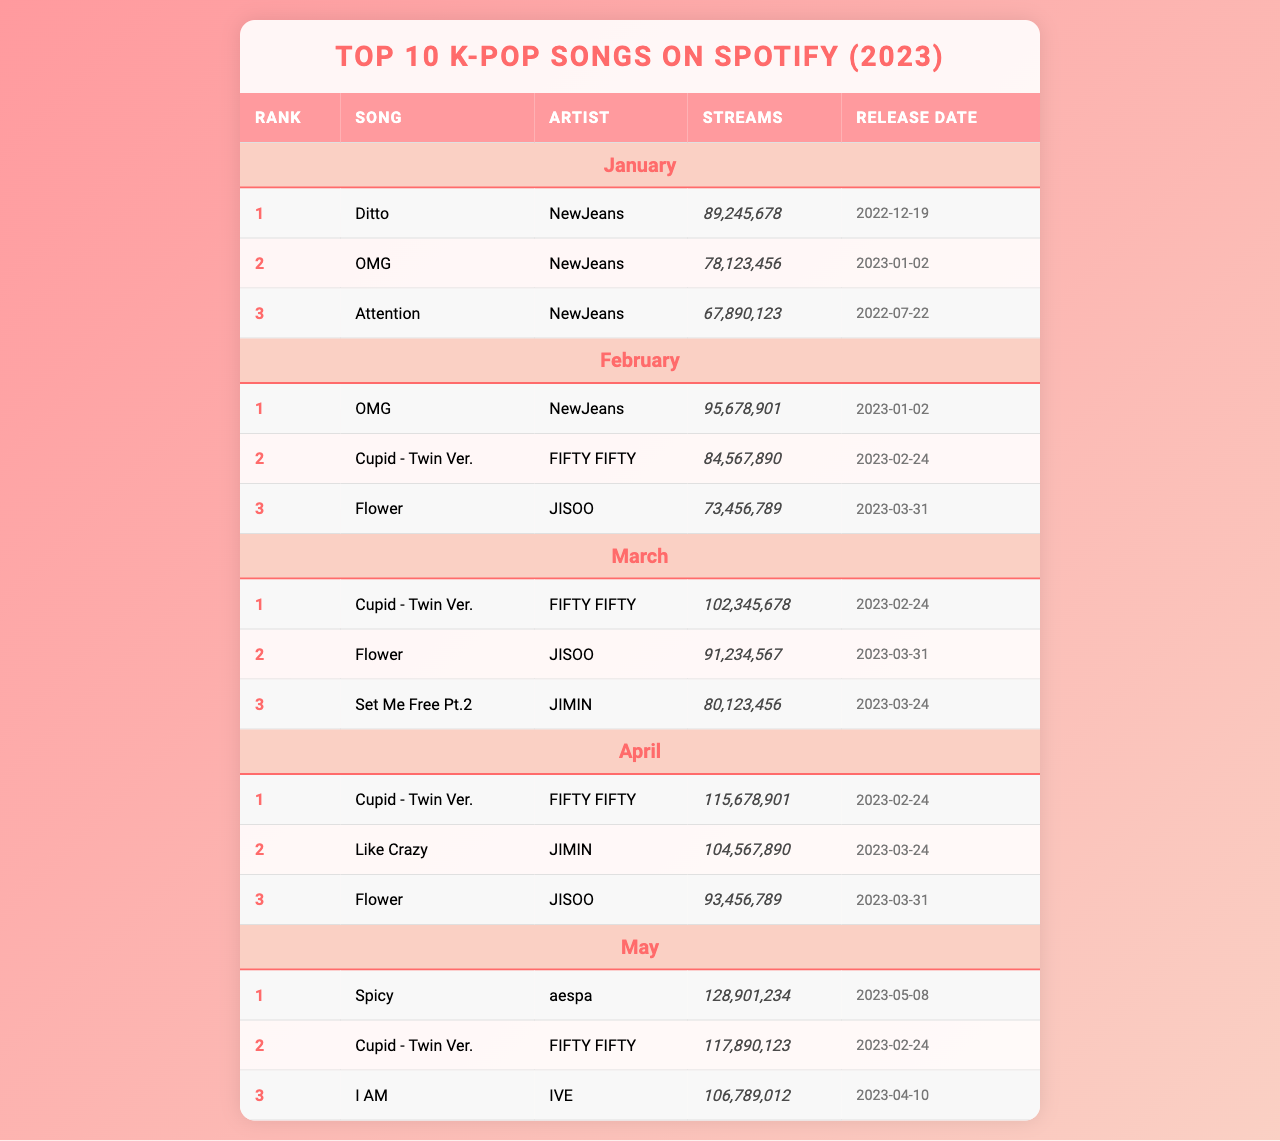What is the highest-ranking song in January? In January, the highest-ranking song is "Ditto" by NewJeans, which is ranked 1st.
Answer: "Ditto" How many streams did "Cupid - Twin Ver." have in March? In March, "Cupid - Twin Ver." had 102,345,678 streams, as indicated in the table under that month.
Answer: 102,345,678 Which song had the most streams in April? In April, "Cupid - Twin Ver." had the most streams with 115,678,901.
Answer: 115,678,901 What is the total number of streams for "Flower" across all months? "Flower" had 73,456,789 streams in February and 93,456,789 in April, total is 73,456,789 + 93,456,789 = 166,913,578.
Answer: 166,913,578 Which month had the song "Like Crazy"? "Like Crazy" is listed as the 2nd ranked song in April.
Answer: April Did "NewJeans" have more than one song in the top 3 of January? NewJeans had three songs in January: "Ditto" (1st), "OMG" (2nd), and "Attention" (3rd). Therefore, the answer is yes.
Answer: Yes What is the average number of streams for "Cupid - Twin Ver." across February, March, and April? "Cupid - Twin Ver." had 84,567,890 streams in February, 102,345,678 in March, and 115,678,901 in April. Total streams are 84,567,890 + 102,345,678 + 115,678,901 = 302,592,469. The average is 302,592,469 / 3 = 100,864,156.
Answer: 100,864,156 Which artist had the most songs listed in the top 3 for any month? "NewJeans" had three songs in the top 3 in January, while "FIFTY FIFTY" had three entries in the top 3 as well, including consecutive months.
Answer: NewJeans and FIFTY FIFTY What is the total number of streams for the top 3 songs in May? "Spicy" had 128,901,234, "Cupid - Twin Ver." had 117,890,123, and "I AM" had 106,789,012. Total streams are 128,901,234 + 117,890,123 + 106,789,012 = 353,580,369.
Answer: 353,580,369 Was "I AM" released before May? "I AM" was released on April 10, which is before May. Therefore, the answer is yes.
Answer: Yes 